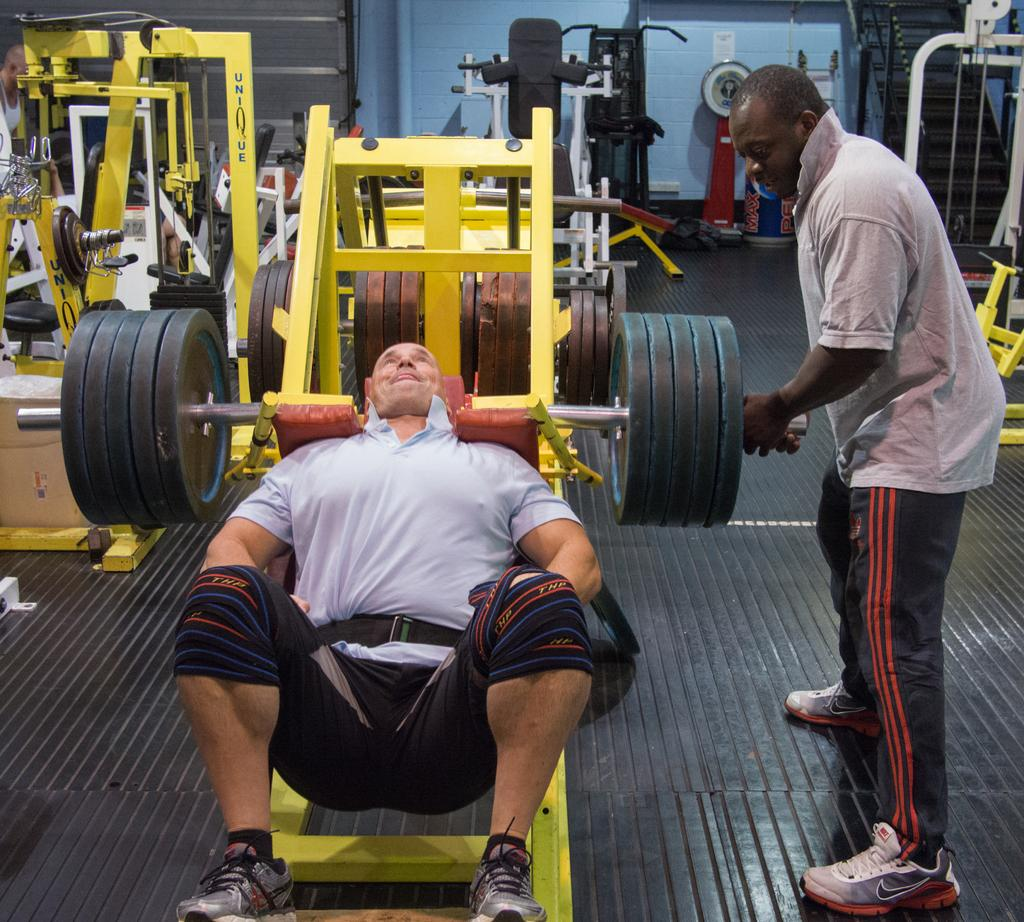How many people are in the image? There are two men in the image. What can be seen on the floor in the image? There is gym equipment on the floor. What architectural features are visible in the background of the image? There are steps and walls in the background of the image. What type of object can be seen in the background of the image? There is a pipe in the background of the image. Can you describe the unspecified objects in the background of the image? Unfortunately, the facts do not specify the nature of the unspecified objects in the background. What color is the pencil that the men are using to draw on the wall in the image? There is no pencil present in the image, nor is there any indication that the men are drawing on the wall. 